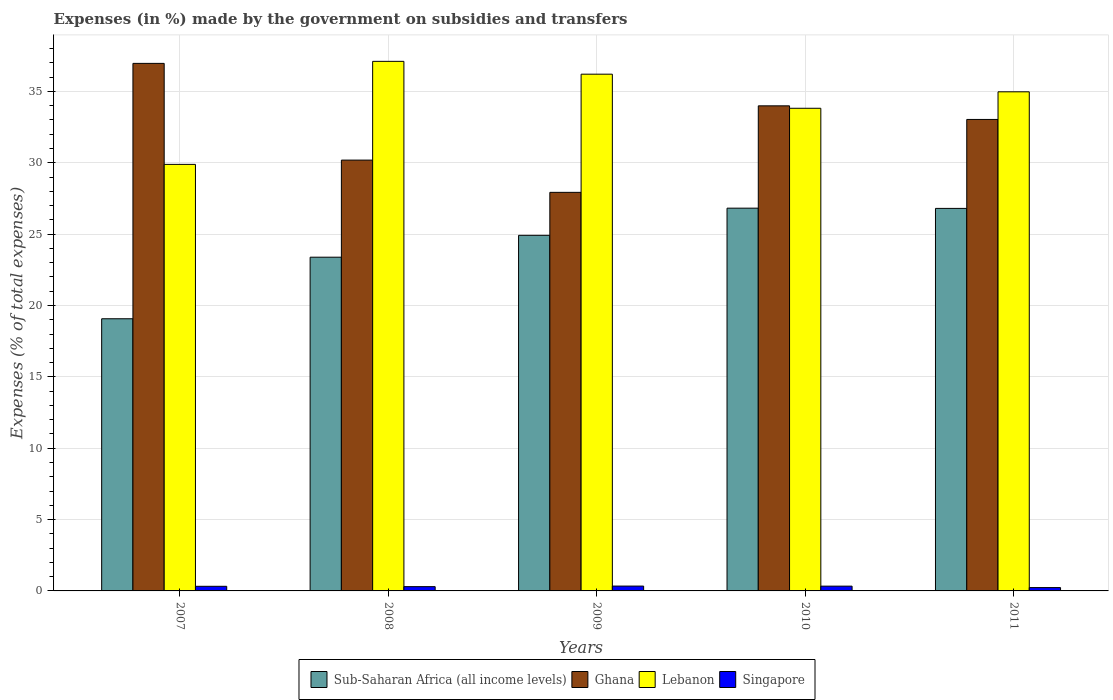How many different coloured bars are there?
Give a very brief answer. 4. Are the number of bars on each tick of the X-axis equal?
Keep it short and to the point. Yes. In how many cases, is the number of bars for a given year not equal to the number of legend labels?
Your answer should be compact. 0. What is the percentage of expenses made by the government on subsidies and transfers in Lebanon in 2008?
Offer a terse response. 37.1. Across all years, what is the maximum percentage of expenses made by the government on subsidies and transfers in Sub-Saharan Africa (all income levels)?
Offer a very short reply. 26.82. Across all years, what is the minimum percentage of expenses made by the government on subsidies and transfers in Lebanon?
Offer a terse response. 29.88. What is the total percentage of expenses made by the government on subsidies and transfers in Ghana in the graph?
Your response must be concise. 162.09. What is the difference between the percentage of expenses made by the government on subsidies and transfers in Ghana in 2009 and that in 2010?
Offer a very short reply. -6.06. What is the difference between the percentage of expenses made by the government on subsidies and transfers in Singapore in 2011 and the percentage of expenses made by the government on subsidies and transfers in Ghana in 2010?
Provide a short and direct response. -33.75. What is the average percentage of expenses made by the government on subsidies and transfers in Sub-Saharan Africa (all income levels) per year?
Your response must be concise. 24.2. In the year 2007, what is the difference between the percentage of expenses made by the government on subsidies and transfers in Sub-Saharan Africa (all income levels) and percentage of expenses made by the government on subsidies and transfers in Singapore?
Your answer should be compact. 18.75. In how many years, is the percentage of expenses made by the government on subsidies and transfers in Singapore greater than 22 %?
Give a very brief answer. 0. What is the ratio of the percentage of expenses made by the government on subsidies and transfers in Ghana in 2007 to that in 2011?
Keep it short and to the point. 1.12. Is the percentage of expenses made by the government on subsidies and transfers in Lebanon in 2010 less than that in 2011?
Provide a short and direct response. Yes. Is the difference between the percentage of expenses made by the government on subsidies and transfers in Sub-Saharan Africa (all income levels) in 2007 and 2011 greater than the difference between the percentage of expenses made by the government on subsidies and transfers in Singapore in 2007 and 2011?
Provide a short and direct response. No. What is the difference between the highest and the second highest percentage of expenses made by the government on subsidies and transfers in Sub-Saharan Africa (all income levels)?
Keep it short and to the point. 0.02. What is the difference between the highest and the lowest percentage of expenses made by the government on subsidies and transfers in Lebanon?
Your answer should be compact. 7.22. In how many years, is the percentage of expenses made by the government on subsidies and transfers in Sub-Saharan Africa (all income levels) greater than the average percentage of expenses made by the government on subsidies and transfers in Sub-Saharan Africa (all income levels) taken over all years?
Give a very brief answer. 3. Is the sum of the percentage of expenses made by the government on subsidies and transfers in Lebanon in 2008 and 2009 greater than the maximum percentage of expenses made by the government on subsidies and transfers in Ghana across all years?
Your response must be concise. Yes. Is it the case that in every year, the sum of the percentage of expenses made by the government on subsidies and transfers in Lebanon and percentage of expenses made by the government on subsidies and transfers in Ghana is greater than the sum of percentage of expenses made by the government on subsidies and transfers in Sub-Saharan Africa (all income levels) and percentage of expenses made by the government on subsidies and transfers in Singapore?
Provide a succinct answer. Yes. What does the 3rd bar from the right in 2007 represents?
Provide a short and direct response. Ghana. How many bars are there?
Provide a short and direct response. 20. Where does the legend appear in the graph?
Provide a short and direct response. Bottom center. How many legend labels are there?
Provide a short and direct response. 4. What is the title of the graph?
Your response must be concise. Expenses (in %) made by the government on subsidies and transfers. Does "Cyprus" appear as one of the legend labels in the graph?
Your answer should be compact. No. What is the label or title of the Y-axis?
Provide a succinct answer. Expenses (% of total expenses). What is the Expenses (% of total expenses) of Sub-Saharan Africa (all income levels) in 2007?
Give a very brief answer. 19.07. What is the Expenses (% of total expenses) in Ghana in 2007?
Ensure brevity in your answer.  36.96. What is the Expenses (% of total expenses) in Lebanon in 2007?
Offer a very short reply. 29.88. What is the Expenses (% of total expenses) of Singapore in 2007?
Provide a short and direct response. 0.32. What is the Expenses (% of total expenses) in Sub-Saharan Africa (all income levels) in 2008?
Offer a very short reply. 23.38. What is the Expenses (% of total expenses) of Ghana in 2008?
Provide a succinct answer. 30.18. What is the Expenses (% of total expenses) in Lebanon in 2008?
Provide a succinct answer. 37.1. What is the Expenses (% of total expenses) in Singapore in 2008?
Ensure brevity in your answer.  0.3. What is the Expenses (% of total expenses) of Sub-Saharan Africa (all income levels) in 2009?
Make the answer very short. 24.91. What is the Expenses (% of total expenses) of Ghana in 2009?
Offer a terse response. 27.92. What is the Expenses (% of total expenses) in Lebanon in 2009?
Provide a short and direct response. 36.2. What is the Expenses (% of total expenses) of Singapore in 2009?
Your answer should be very brief. 0.34. What is the Expenses (% of total expenses) of Sub-Saharan Africa (all income levels) in 2010?
Keep it short and to the point. 26.82. What is the Expenses (% of total expenses) in Ghana in 2010?
Offer a very short reply. 33.99. What is the Expenses (% of total expenses) of Lebanon in 2010?
Offer a terse response. 33.82. What is the Expenses (% of total expenses) in Singapore in 2010?
Your response must be concise. 0.33. What is the Expenses (% of total expenses) of Sub-Saharan Africa (all income levels) in 2011?
Ensure brevity in your answer.  26.8. What is the Expenses (% of total expenses) of Ghana in 2011?
Offer a very short reply. 33.03. What is the Expenses (% of total expenses) of Lebanon in 2011?
Give a very brief answer. 34.97. What is the Expenses (% of total expenses) of Singapore in 2011?
Your response must be concise. 0.23. Across all years, what is the maximum Expenses (% of total expenses) in Sub-Saharan Africa (all income levels)?
Provide a short and direct response. 26.82. Across all years, what is the maximum Expenses (% of total expenses) of Ghana?
Give a very brief answer. 36.96. Across all years, what is the maximum Expenses (% of total expenses) in Lebanon?
Your answer should be very brief. 37.1. Across all years, what is the maximum Expenses (% of total expenses) of Singapore?
Your answer should be very brief. 0.34. Across all years, what is the minimum Expenses (% of total expenses) of Sub-Saharan Africa (all income levels)?
Give a very brief answer. 19.07. Across all years, what is the minimum Expenses (% of total expenses) of Ghana?
Provide a short and direct response. 27.92. Across all years, what is the minimum Expenses (% of total expenses) in Lebanon?
Your answer should be very brief. 29.88. Across all years, what is the minimum Expenses (% of total expenses) in Singapore?
Give a very brief answer. 0.23. What is the total Expenses (% of total expenses) of Sub-Saharan Africa (all income levels) in the graph?
Offer a terse response. 120.98. What is the total Expenses (% of total expenses) in Ghana in the graph?
Your answer should be very brief. 162.09. What is the total Expenses (% of total expenses) of Lebanon in the graph?
Ensure brevity in your answer.  171.98. What is the total Expenses (% of total expenses) in Singapore in the graph?
Offer a terse response. 1.53. What is the difference between the Expenses (% of total expenses) in Sub-Saharan Africa (all income levels) in 2007 and that in 2008?
Your response must be concise. -4.31. What is the difference between the Expenses (% of total expenses) of Ghana in 2007 and that in 2008?
Keep it short and to the point. 6.78. What is the difference between the Expenses (% of total expenses) of Lebanon in 2007 and that in 2008?
Offer a terse response. -7.22. What is the difference between the Expenses (% of total expenses) of Singapore in 2007 and that in 2008?
Make the answer very short. 0.02. What is the difference between the Expenses (% of total expenses) of Sub-Saharan Africa (all income levels) in 2007 and that in 2009?
Your answer should be very brief. -5.85. What is the difference between the Expenses (% of total expenses) in Ghana in 2007 and that in 2009?
Make the answer very short. 9.04. What is the difference between the Expenses (% of total expenses) in Lebanon in 2007 and that in 2009?
Your answer should be compact. -6.32. What is the difference between the Expenses (% of total expenses) in Singapore in 2007 and that in 2009?
Ensure brevity in your answer.  -0.02. What is the difference between the Expenses (% of total expenses) of Sub-Saharan Africa (all income levels) in 2007 and that in 2010?
Provide a short and direct response. -7.75. What is the difference between the Expenses (% of total expenses) of Ghana in 2007 and that in 2010?
Offer a very short reply. 2.97. What is the difference between the Expenses (% of total expenses) of Lebanon in 2007 and that in 2010?
Your response must be concise. -3.93. What is the difference between the Expenses (% of total expenses) in Singapore in 2007 and that in 2010?
Your answer should be compact. -0.01. What is the difference between the Expenses (% of total expenses) in Sub-Saharan Africa (all income levels) in 2007 and that in 2011?
Offer a terse response. -7.73. What is the difference between the Expenses (% of total expenses) of Ghana in 2007 and that in 2011?
Provide a succinct answer. 3.93. What is the difference between the Expenses (% of total expenses) in Lebanon in 2007 and that in 2011?
Your answer should be compact. -5.09. What is the difference between the Expenses (% of total expenses) in Singapore in 2007 and that in 2011?
Your response must be concise. 0.09. What is the difference between the Expenses (% of total expenses) of Sub-Saharan Africa (all income levels) in 2008 and that in 2009?
Your response must be concise. -1.53. What is the difference between the Expenses (% of total expenses) of Ghana in 2008 and that in 2009?
Keep it short and to the point. 2.26. What is the difference between the Expenses (% of total expenses) in Lebanon in 2008 and that in 2009?
Offer a terse response. 0.9. What is the difference between the Expenses (% of total expenses) in Singapore in 2008 and that in 2009?
Provide a short and direct response. -0.04. What is the difference between the Expenses (% of total expenses) of Sub-Saharan Africa (all income levels) in 2008 and that in 2010?
Keep it short and to the point. -3.44. What is the difference between the Expenses (% of total expenses) in Ghana in 2008 and that in 2010?
Your response must be concise. -3.8. What is the difference between the Expenses (% of total expenses) of Lebanon in 2008 and that in 2010?
Give a very brief answer. 3.29. What is the difference between the Expenses (% of total expenses) of Singapore in 2008 and that in 2010?
Make the answer very short. -0.03. What is the difference between the Expenses (% of total expenses) in Sub-Saharan Africa (all income levels) in 2008 and that in 2011?
Keep it short and to the point. -3.42. What is the difference between the Expenses (% of total expenses) of Ghana in 2008 and that in 2011?
Ensure brevity in your answer.  -2.85. What is the difference between the Expenses (% of total expenses) in Lebanon in 2008 and that in 2011?
Your answer should be compact. 2.13. What is the difference between the Expenses (% of total expenses) in Singapore in 2008 and that in 2011?
Offer a terse response. 0.07. What is the difference between the Expenses (% of total expenses) in Sub-Saharan Africa (all income levels) in 2009 and that in 2010?
Provide a short and direct response. -1.9. What is the difference between the Expenses (% of total expenses) of Ghana in 2009 and that in 2010?
Your answer should be very brief. -6.06. What is the difference between the Expenses (% of total expenses) of Lebanon in 2009 and that in 2010?
Your answer should be very brief. 2.39. What is the difference between the Expenses (% of total expenses) of Singapore in 2009 and that in 2010?
Offer a very short reply. 0. What is the difference between the Expenses (% of total expenses) in Sub-Saharan Africa (all income levels) in 2009 and that in 2011?
Ensure brevity in your answer.  -1.89. What is the difference between the Expenses (% of total expenses) of Ghana in 2009 and that in 2011?
Keep it short and to the point. -5.11. What is the difference between the Expenses (% of total expenses) in Lebanon in 2009 and that in 2011?
Make the answer very short. 1.23. What is the difference between the Expenses (% of total expenses) in Singapore in 2009 and that in 2011?
Your answer should be compact. 0.11. What is the difference between the Expenses (% of total expenses) of Sub-Saharan Africa (all income levels) in 2010 and that in 2011?
Give a very brief answer. 0.02. What is the difference between the Expenses (% of total expenses) of Ghana in 2010 and that in 2011?
Provide a short and direct response. 0.95. What is the difference between the Expenses (% of total expenses) in Lebanon in 2010 and that in 2011?
Provide a succinct answer. -1.15. What is the difference between the Expenses (% of total expenses) of Singapore in 2010 and that in 2011?
Keep it short and to the point. 0.1. What is the difference between the Expenses (% of total expenses) in Sub-Saharan Africa (all income levels) in 2007 and the Expenses (% of total expenses) in Ghana in 2008?
Give a very brief answer. -11.12. What is the difference between the Expenses (% of total expenses) of Sub-Saharan Africa (all income levels) in 2007 and the Expenses (% of total expenses) of Lebanon in 2008?
Give a very brief answer. -18.03. What is the difference between the Expenses (% of total expenses) in Sub-Saharan Africa (all income levels) in 2007 and the Expenses (% of total expenses) in Singapore in 2008?
Your answer should be very brief. 18.77. What is the difference between the Expenses (% of total expenses) in Ghana in 2007 and the Expenses (% of total expenses) in Lebanon in 2008?
Your answer should be very brief. -0.14. What is the difference between the Expenses (% of total expenses) in Ghana in 2007 and the Expenses (% of total expenses) in Singapore in 2008?
Offer a very short reply. 36.66. What is the difference between the Expenses (% of total expenses) of Lebanon in 2007 and the Expenses (% of total expenses) of Singapore in 2008?
Offer a very short reply. 29.58. What is the difference between the Expenses (% of total expenses) in Sub-Saharan Africa (all income levels) in 2007 and the Expenses (% of total expenses) in Ghana in 2009?
Make the answer very short. -8.86. What is the difference between the Expenses (% of total expenses) of Sub-Saharan Africa (all income levels) in 2007 and the Expenses (% of total expenses) of Lebanon in 2009?
Keep it short and to the point. -17.14. What is the difference between the Expenses (% of total expenses) of Sub-Saharan Africa (all income levels) in 2007 and the Expenses (% of total expenses) of Singapore in 2009?
Give a very brief answer. 18.73. What is the difference between the Expenses (% of total expenses) in Ghana in 2007 and the Expenses (% of total expenses) in Lebanon in 2009?
Keep it short and to the point. 0.76. What is the difference between the Expenses (% of total expenses) of Ghana in 2007 and the Expenses (% of total expenses) of Singapore in 2009?
Make the answer very short. 36.62. What is the difference between the Expenses (% of total expenses) of Lebanon in 2007 and the Expenses (% of total expenses) of Singapore in 2009?
Provide a succinct answer. 29.55. What is the difference between the Expenses (% of total expenses) of Sub-Saharan Africa (all income levels) in 2007 and the Expenses (% of total expenses) of Ghana in 2010?
Your response must be concise. -14.92. What is the difference between the Expenses (% of total expenses) of Sub-Saharan Africa (all income levels) in 2007 and the Expenses (% of total expenses) of Lebanon in 2010?
Give a very brief answer. -14.75. What is the difference between the Expenses (% of total expenses) in Sub-Saharan Africa (all income levels) in 2007 and the Expenses (% of total expenses) in Singapore in 2010?
Offer a terse response. 18.73. What is the difference between the Expenses (% of total expenses) in Ghana in 2007 and the Expenses (% of total expenses) in Lebanon in 2010?
Offer a terse response. 3.14. What is the difference between the Expenses (% of total expenses) in Ghana in 2007 and the Expenses (% of total expenses) in Singapore in 2010?
Make the answer very short. 36.63. What is the difference between the Expenses (% of total expenses) in Lebanon in 2007 and the Expenses (% of total expenses) in Singapore in 2010?
Your answer should be very brief. 29.55. What is the difference between the Expenses (% of total expenses) of Sub-Saharan Africa (all income levels) in 2007 and the Expenses (% of total expenses) of Ghana in 2011?
Ensure brevity in your answer.  -13.96. What is the difference between the Expenses (% of total expenses) in Sub-Saharan Africa (all income levels) in 2007 and the Expenses (% of total expenses) in Lebanon in 2011?
Provide a short and direct response. -15.9. What is the difference between the Expenses (% of total expenses) in Sub-Saharan Africa (all income levels) in 2007 and the Expenses (% of total expenses) in Singapore in 2011?
Your answer should be compact. 18.84. What is the difference between the Expenses (% of total expenses) in Ghana in 2007 and the Expenses (% of total expenses) in Lebanon in 2011?
Offer a terse response. 1.99. What is the difference between the Expenses (% of total expenses) of Ghana in 2007 and the Expenses (% of total expenses) of Singapore in 2011?
Provide a short and direct response. 36.73. What is the difference between the Expenses (% of total expenses) in Lebanon in 2007 and the Expenses (% of total expenses) in Singapore in 2011?
Offer a terse response. 29.65. What is the difference between the Expenses (% of total expenses) of Sub-Saharan Africa (all income levels) in 2008 and the Expenses (% of total expenses) of Ghana in 2009?
Offer a very short reply. -4.54. What is the difference between the Expenses (% of total expenses) in Sub-Saharan Africa (all income levels) in 2008 and the Expenses (% of total expenses) in Lebanon in 2009?
Your answer should be very brief. -12.82. What is the difference between the Expenses (% of total expenses) in Sub-Saharan Africa (all income levels) in 2008 and the Expenses (% of total expenses) in Singapore in 2009?
Your answer should be compact. 23.04. What is the difference between the Expenses (% of total expenses) of Ghana in 2008 and the Expenses (% of total expenses) of Lebanon in 2009?
Keep it short and to the point. -6.02. What is the difference between the Expenses (% of total expenses) of Ghana in 2008 and the Expenses (% of total expenses) of Singapore in 2009?
Provide a short and direct response. 29.85. What is the difference between the Expenses (% of total expenses) in Lebanon in 2008 and the Expenses (% of total expenses) in Singapore in 2009?
Ensure brevity in your answer.  36.76. What is the difference between the Expenses (% of total expenses) in Sub-Saharan Africa (all income levels) in 2008 and the Expenses (% of total expenses) in Ghana in 2010?
Make the answer very short. -10.6. What is the difference between the Expenses (% of total expenses) of Sub-Saharan Africa (all income levels) in 2008 and the Expenses (% of total expenses) of Lebanon in 2010?
Your response must be concise. -10.43. What is the difference between the Expenses (% of total expenses) in Sub-Saharan Africa (all income levels) in 2008 and the Expenses (% of total expenses) in Singapore in 2010?
Offer a very short reply. 23.05. What is the difference between the Expenses (% of total expenses) of Ghana in 2008 and the Expenses (% of total expenses) of Lebanon in 2010?
Keep it short and to the point. -3.63. What is the difference between the Expenses (% of total expenses) in Ghana in 2008 and the Expenses (% of total expenses) in Singapore in 2010?
Give a very brief answer. 29.85. What is the difference between the Expenses (% of total expenses) in Lebanon in 2008 and the Expenses (% of total expenses) in Singapore in 2010?
Your response must be concise. 36.77. What is the difference between the Expenses (% of total expenses) in Sub-Saharan Africa (all income levels) in 2008 and the Expenses (% of total expenses) in Ghana in 2011?
Ensure brevity in your answer.  -9.65. What is the difference between the Expenses (% of total expenses) in Sub-Saharan Africa (all income levels) in 2008 and the Expenses (% of total expenses) in Lebanon in 2011?
Offer a terse response. -11.59. What is the difference between the Expenses (% of total expenses) in Sub-Saharan Africa (all income levels) in 2008 and the Expenses (% of total expenses) in Singapore in 2011?
Your answer should be very brief. 23.15. What is the difference between the Expenses (% of total expenses) in Ghana in 2008 and the Expenses (% of total expenses) in Lebanon in 2011?
Your response must be concise. -4.79. What is the difference between the Expenses (% of total expenses) in Ghana in 2008 and the Expenses (% of total expenses) in Singapore in 2011?
Keep it short and to the point. 29.95. What is the difference between the Expenses (% of total expenses) in Lebanon in 2008 and the Expenses (% of total expenses) in Singapore in 2011?
Give a very brief answer. 36.87. What is the difference between the Expenses (% of total expenses) of Sub-Saharan Africa (all income levels) in 2009 and the Expenses (% of total expenses) of Ghana in 2010?
Give a very brief answer. -9.07. What is the difference between the Expenses (% of total expenses) of Sub-Saharan Africa (all income levels) in 2009 and the Expenses (% of total expenses) of Lebanon in 2010?
Provide a short and direct response. -8.9. What is the difference between the Expenses (% of total expenses) in Sub-Saharan Africa (all income levels) in 2009 and the Expenses (% of total expenses) in Singapore in 2010?
Your answer should be compact. 24.58. What is the difference between the Expenses (% of total expenses) in Ghana in 2009 and the Expenses (% of total expenses) in Lebanon in 2010?
Your answer should be compact. -5.89. What is the difference between the Expenses (% of total expenses) in Ghana in 2009 and the Expenses (% of total expenses) in Singapore in 2010?
Make the answer very short. 27.59. What is the difference between the Expenses (% of total expenses) of Lebanon in 2009 and the Expenses (% of total expenses) of Singapore in 2010?
Ensure brevity in your answer.  35.87. What is the difference between the Expenses (% of total expenses) of Sub-Saharan Africa (all income levels) in 2009 and the Expenses (% of total expenses) of Ghana in 2011?
Make the answer very short. -8.12. What is the difference between the Expenses (% of total expenses) in Sub-Saharan Africa (all income levels) in 2009 and the Expenses (% of total expenses) in Lebanon in 2011?
Provide a short and direct response. -10.06. What is the difference between the Expenses (% of total expenses) of Sub-Saharan Africa (all income levels) in 2009 and the Expenses (% of total expenses) of Singapore in 2011?
Your response must be concise. 24.68. What is the difference between the Expenses (% of total expenses) of Ghana in 2009 and the Expenses (% of total expenses) of Lebanon in 2011?
Your answer should be compact. -7.05. What is the difference between the Expenses (% of total expenses) in Ghana in 2009 and the Expenses (% of total expenses) in Singapore in 2011?
Make the answer very short. 27.69. What is the difference between the Expenses (% of total expenses) of Lebanon in 2009 and the Expenses (% of total expenses) of Singapore in 2011?
Give a very brief answer. 35.97. What is the difference between the Expenses (% of total expenses) of Sub-Saharan Africa (all income levels) in 2010 and the Expenses (% of total expenses) of Ghana in 2011?
Offer a terse response. -6.22. What is the difference between the Expenses (% of total expenses) in Sub-Saharan Africa (all income levels) in 2010 and the Expenses (% of total expenses) in Lebanon in 2011?
Offer a very short reply. -8.15. What is the difference between the Expenses (% of total expenses) of Sub-Saharan Africa (all income levels) in 2010 and the Expenses (% of total expenses) of Singapore in 2011?
Provide a short and direct response. 26.58. What is the difference between the Expenses (% of total expenses) of Ghana in 2010 and the Expenses (% of total expenses) of Lebanon in 2011?
Provide a short and direct response. -0.98. What is the difference between the Expenses (% of total expenses) in Ghana in 2010 and the Expenses (% of total expenses) in Singapore in 2011?
Provide a succinct answer. 33.75. What is the difference between the Expenses (% of total expenses) in Lebanon in 2010 and the Expenses (% of total expenses) in Singapore in 2011?
Ensure brevity in your answer.  33.58. What is the average Expenses (% of total expenses) of Sub-Saharan Africa (all income levels) per year?
Keep it short and to the point. 24.2. What is the average Expenses (% of total expenses) in Ghana per year?
Keep it short and to the point. 32.42. What is the average Expenses (% of total expenses) in Lebanon per year?
Offer a terse response. 34.4. What is the average Expenses (% of total expenses) in Singapore per year?
Your answer should be compact. 0.31. In the year 2007, what is the difference between the Expenses (% of total expenses) in Sub-Saharan Africa (all income levels) and Expenses (% of total expenses) in Ghana?
Offer a very short reply. -17.89. In the year 2007, what is the difference between the Expenses (% of total expenses) in Sub-Saharan Africa (all income levels) and Expenses (% of total expenses) in Lebanon?
Your response must be concise. -10.82. In the year 2007, what is the difference between the Expenses (% of total expenses) in Sub-Saharan Africa (all income levels) and Expenses (% of total expenses) in Singapore?
Your answer should be compact. 18.75. In the year 2007, what is the difference between the Expenses (% of total expenses) of Ghana and Expenses (% of total expenses) of Lebanon?
Your response must be concise. 7.08. In the year 2007, what is the difference between the Expenses (% of total expenses) of Ghana and Expenses (% of total expenses) of Singapore?
Give a very brief answer. 36.64. In the year 2007, what is the difference between the Expenses (% of total expenses) of Lebanon and Expenses (% of total expenses) of Singapore?
Offer a terse response. 29.56. In the year 2008, what is the difference between the Expenses (% of total expenses) of Sub-Saharan Africa (all income levels) and Expenses (% of total expenses) of Ghana?
Make the answer very short. -6.8. In the year 2008, what is the difference between the Expenses (% of total expenses) in Sub-Saharan Africa (all income levels) and Expenses (% of total expenses) in Lebanon?
Your answer should be very brief. -13.72. In the year 2008, what is the difference between the Expenses (% of total expenses) of Sub-Saharan Africa (all income levels) and Expenses (% of total expenses) of Singapore?
Provide a succinct answer. 23.08. In the year 2008, what is the difference between the Expenses (% of total expenses) in Ghana and Expenses (% of total expenses) in Lebanon?
Offer a terse response. -6.92. In the year 2008, what is the difference between the Expenses (% of total expenses) of Ghana and Expenses (% of total expenses) of Singapore?
Offer a terse response. 29.88. In the year 2008, what is the difference between the Expenses (% of total expenses) in Lebanon and Expenses (% of total expenses) in Singapore?
Provide a short and direct response. 36.8. In the year 2009, what is the difference between the Expenses (% of total expenses) in Sub-Saharan Africa (all income levels) and Expenses (% of total expenses) in Ghana?
Give a very brief answer. -3.01. In the year 2009, what is the difference between the Expenses (% of total expenses) in Sub-Saharan Africa (all income levels) and Expenses (% of total expenses) in Lebanon?
Provide a succinct answer. -11.29. In the year 2009, what is the difference between the Expenses (% of total expenses) in Sub-Saharan Africa (all income levels) and Expenses (% of total expenses) in Singapore?
Your answer should be compact. 24.58. In the year 2009, what is the difference between the Expenses (% of total expenses) in Ghana and Expenses (% of total expenses) in Lebanon?
Your answer should be compact. -8.28. In the year 2009, what is the difference between the Expenses (% of total expenses) in Ghana and Expenses (% of total expenses) in Singapore?
Offer a terse response. 27.59. In the year 2009, what is the difference between the Expenses (% of total expenses) in Lebanon and Expenses (% of total expenses) in Singapore?
Offer a terse response. 35.87. In the year 2010, what is the difference between the Expenses (% of total expenses) in Sub-Saharan Africa (all income levels) and Expenses (% of total expenses) in Ghana?
Your answer should be compact. -7.17. In the year 2010, what is the difference between the Expenses (% of total expenses) in Sub-Saharan Africa (all income levels) and Expenses (% of total expenses) in Lebanon?
Keep it short and to the point. -7. In the year 2010, what is the difference between the Expenses (% of total expenses) of Sub-Saharan Africa (all income levels) and Expenses (% of total expenses) of Singapore?
Provide a short and direct response. 26.48. In the year 2010, what is the difference between the Expenses (% of total expenses) in Ghana and Expenses (% of total expenses) in Lebanon?
Your response must be concise. 0.17. In the year 2010, what is the difference between the Expenses (% of total expenses) in Ghana and Expenses (% of total expenses) in Singapore?
Keep it short and to the point. 33.65. In the year 2010, what is the difference between the Expenses (% of total expenses) of Lebanon and Expenses (% of total expenses) of Singapore?
Provide a short and direct response. 33.48. In the year 2011, what is the difference between the Expenses (% of total expenses) in Sub-Saharan Africa (all income levels) and Expenses (% of total expenses) in Ghana?
Your answer should be compact. -6.23. In the year 2011, what is the difference between the Expenses (% of total expenses) in Sub-Saharan Africa (all income levels) and Expenses (% of total expenses) in Lebanon?
Give a very brief answer. -8.17. In the year 2011, what is the difference between the Expenses (% of total expenses) in Sub-Saharan Africa (all income levels) and Expenses (% of total expenses) in Singapore?
Your response must be concise. 26.57. In the year 2011, what is the difference between the Expenses (% of total expenses) in Ghana and Expenses (% of total expenses) in Lebanon?
Ensure brevity in your answer.  -1.94. In the year 2011, what is the difference between the Expenses (% of total expenses) of Ghana and Expenses (% of total expenses) of Singapore?
Your answer should be compact. 32.8. In the year 2011, what is the difference between the Expenses (% of total expenses) in Lebanon and Expenses (% of total expenses) in Singapore?
Provide a succinct answer. 34.74. What is the ratio of the Expenses (% of total expenses) of Sub-Saharan Africa (all income levels) in 2007 to that in 2008?
Ensure brevity in your answer.  0.82. What is the ratio of the Expenses (% of total expenses) in Ghana in 2007 to that in 2008?
Offer a terse response. 1.22. What is the ratio of the Expenses (% of total expenses) in Lebanon in 2007 to that in 2008?
Make the answer very short. 0.81. What is the ratio of the Expenses (% of total expenses) of Singapore in 2007 to that in 2008?
Offer a very short reply. 1.08. What is the ratio of the Expenses (% of total expenses) of Sub-Saharan Africa (all income levels) in 2007 to that in 2009?
Offer a terse response. 0.77. What is the ratio of the Expenses (% of total expenses) in Ghana in 2007 to that in 2009?
Your answer should be very brief. 1.32. What is the ratio of the Expenses (% of total expenses) of Lebanon in 2007 to that in 2009?
Ensure brevity in your answer.  0.83. What is the ratio of the Expenses (% of total expenses) of Singapore in 2007 to that in 2009?
Keep it short and to the point. 0.95. What is the ratio of the Expenses (% of total expenses) in Sub-Saharan Africa (all income levels) in 2007 to that in 2010?
Ensure brevity in your answer.  0.71. What is the ratio of the Expenses (% of total expenses) of Ghana in 2007 to that in 2010?
Give a very brief answer. 1.09. What is the ratio of the Expenses (% of total expenses) in Lebanon in 2007 to that in 2010?
Your response must be concise. 0.88. What is the ratio of the Expenses (% of total expenses) of Sub-Saharan Africa (all income levels) in 2007 to that in 2011?
Ensure brevity in your answer.  0.71. What is the ratio of the Expenses (% of total expenses) of Ghana in 2007 to that in 2011?
Your answer should be very brief. 1.12. What is the ratio of the Expenses (% of total expenses) in Lebanon in 2007 to that in 2011?
Offer a very short reply. 0.85. What is the ratio of the Expenses (% of total expenses) of Singapore in 2007 to that in 2011?
Your response must be concise. 1.38. What is the ratio of the Expenses (% of total expenses) of Sub-Saharan Africa (all income levels) in 2008 to that in 2009?
Your answer should be compact. 0.94. What is the ratio of the Expenses (% of total expenses) of Ghana in 2008 to that in 2009?
Provide a short and direct response. 1.08. What is the ratio of the Expenses (% of total expenses) in Lebanon in 2008 to that in 2009?
Offer a terse response. 1.02. What is the ratio of the Expenses (% of total expenses) in Singapore in 2008 to that in 2009?
Your answer should be compact. 0.88. What is the ratio of the Expenses (% of total expenses) in Sub-Saharan Africa (all income levels) in 2008 to that in 2010?
Keep it short and to the point. 0.87. What is the ratio of the Expenses (% of total expenses) of Ghana in 2008 to that in 2010?
Make the answer very short. 0.89. What is the ratio of the Expenses (% of total expenses) in Lebanon in 2008 to that in 2010?
Your response must be concise. 1.1. What is the ratio of the Expenses (% of total expenses) of Singapore in 2008 to that in 2010?
Provide a succinct answer. 0.9. What is the ratio of the Expenses (% of total expenses) of Sub-Saharan Africa (all income levels) in 2008 to that in 2011?
Provide a short and direct response. 0.87. What is the ratio of the Expenses (% of total expenses) in Ghana in 2008 to that in 2011?
Your response must be concise. 0.91. What is the ratio of the Expenses (% of total expenses) of Lebanon in 2008 to that in 2011?
Provide a succinct answer. 1.06. What is the ratio of the Expenses (% of total expenses) of Singapore in 2008 to that in 2011?
Make the answer very short. 1.28. What is the ratio of the Expenses (% of total expenses) in Sub-Saharan Africa (all income levels) in 2009 to that in 2010?
Make the answer very short. 0.93. What is the ratio of the Expenses (% of total expenses) of Ghana in 2009 to that in 2010?
Give a very brief answer. 0.82. What is the ratio of the Expenses (% of total expenses) in Lebanon in 2009 to that in 2010?
Provide a short and direct response. 1.07. What is the ratio of the Expenses (% of total expenses) in Singapore in 2009 to that in 2010?
Your answer should be very brief. 1.01. What is the ratio of the Expenses (% of total expenses) of Sub-Saharan Africa (all income levels) in 2009 to that in 2011?
Your answer should be very brief. 0.93. What is the ratio of the Expenses (% of total expenses) of Ghana in 2009 to that in 2011?
Offer a very short reply. 0.85. What is the ratio of the Expenses (% of total expenses) in Lebanon in 2009 to that in 2011?
Give a very brief answer. 1.04. What is the ratio of the Expenses (% of total expenses) in Singapore in 2009 to that in 2011?
Offer a very short reply. 1.45. What is the ratio of the Expenses (% of total expenses) in Ghana in 2010 to that in 2011?
Your response must be concise. 1.03. What is the ratio of the Expenses (% of total expenses) in Singapore in 2010 to that in 2011?
Your response must be concise. 1.43. What is the difference between the highest and the second highest Expenses (% of total expenses) of Sub-Saharan Africa (all income levels)?
Ensure brevity in your answer.  0.02. What is the difference between the highest and the second highest Expenses (% of total expenses) in Ghana?
Ensure brevity in your answer.  2.97. What is the difference between the highest and the second highest Expenses (% of total expenses) in Lebanon?
Ensure brevity in your answer.  0.9. What is the difference between the highest and the second highest Expenses (% of total expenses) in Singapore?
Your response must be concise. 0. What is the difference between the highest and the lowest Expenses (% of total expenses) in Sub-Saharan Africa (all income levels)?
Offer a very short reply. 7.75. What is the difference between the highest and the lowest Expenses (% of total expenses) of Ghana?
Give a very brief answer. 9.04. What is the difference between the highest and the lowest Expenses (% of total expenses) of Lebanon?
Offer a terse response. 7.22. What is the difference between the highest and the lowest Expenses (% of total expenses) of Singapore?
Give a very brief answer. 0.11. 